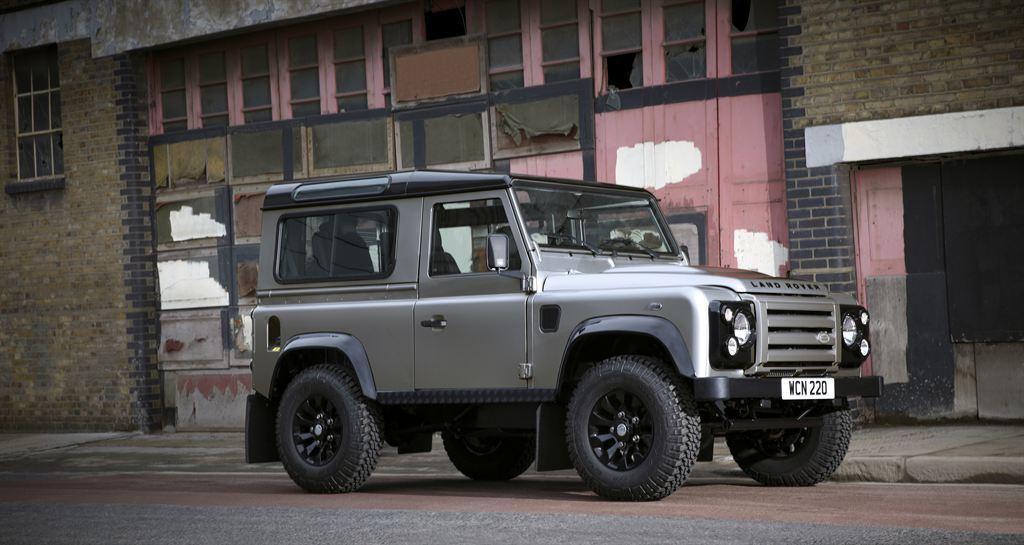How would you summarize this image in a sentence or two? This image is clicked outside. There is a jeep in the middle. There is a building in the middle. Jeep has number plate, lights, wheels. 